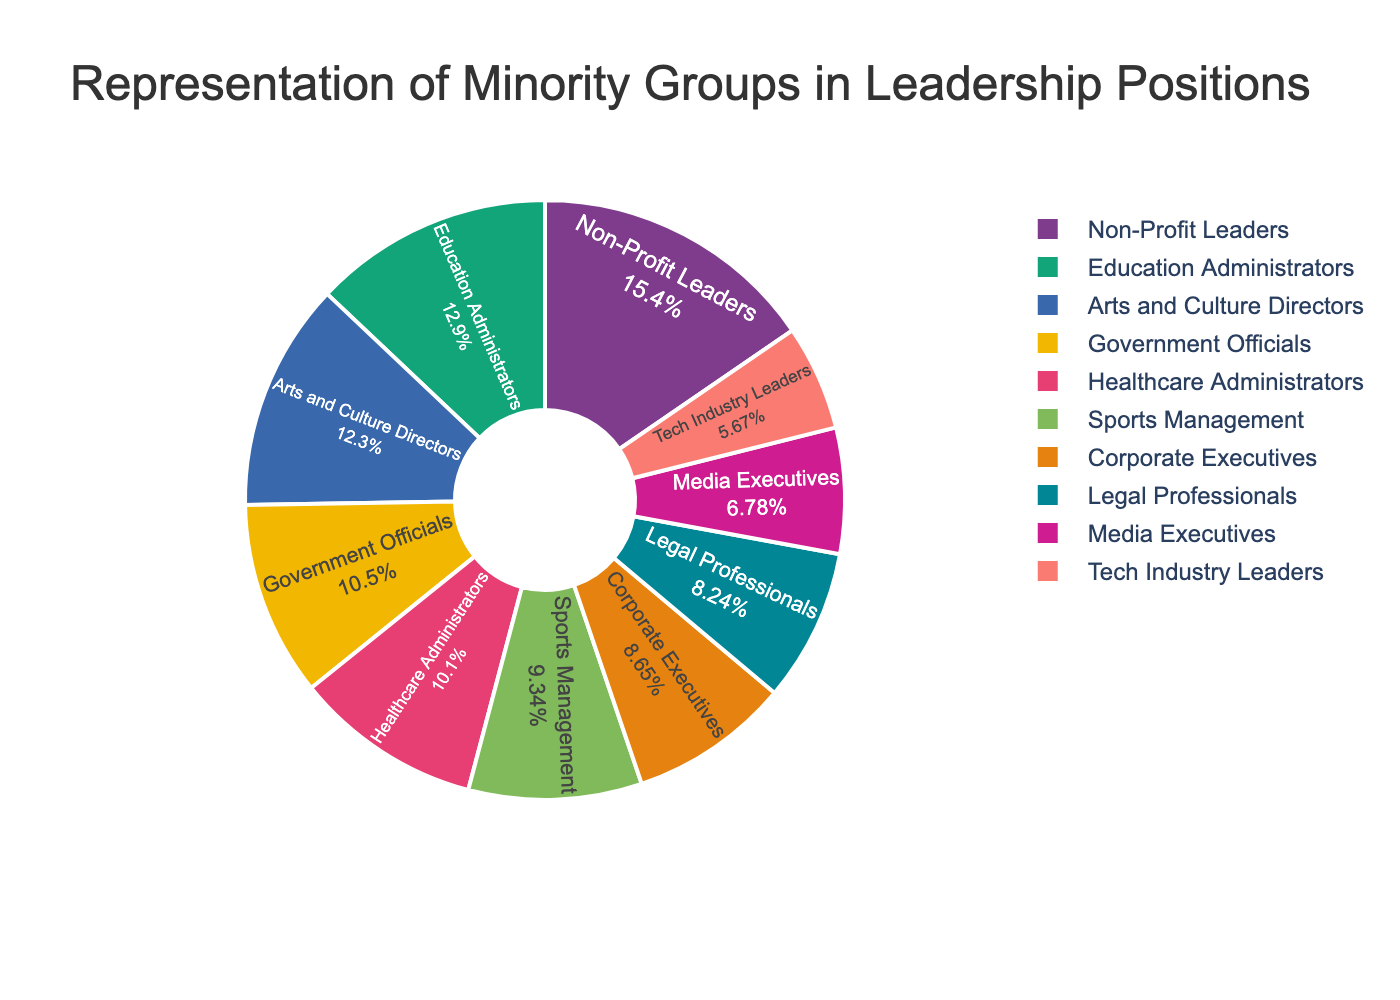Which sector has the highest percentage of minority representation? The chart shows the percentage of minority representation in different sectors. By looking at the percentage values for each sector, we can see that Non-Profit Leaders have the highest percentage at 22.3%.
Answer: Non-Profit Leaders Which sector has the lowest percentage of minority representation? By comparing the percentage values of each sector in the chart, we find that Tech Industry Leaders have the lowest percentage at 8.2%.
Answer: Tech Industry Leaders How much higher is the percentage of minority representation in Non-Profit Leaders compared to Media Executives? The percentage for Non-Profit Leaders is 22.3%, and for Media Executives, it is 9.8%. The difference can be calculated as 22.3% - 9.8% = 12.5%.
Answer: 12.5% What is the combined percentage of minority representation in Government Officials and Education Administrators? The chart shows that Government Officials have 15.2% representation and Education Administrators have 18.7%. Adding these together, we get 15.2% + 18.7% = 33.9%.
Answer: 33.9% Are there more sectors with minority representation percentages greater than 15% or less than 15%? To answer this, count the sectors with more than 15% representation (Government Officials, Education Administrators, Non-Profit Leaders, and Arts and Culture Directors) which are 4 sectors. Then count the sectors with less than 15% (Corporate Executives, Media Executives, Healthcare Administrators, Legal Professionals, Tech Industry Leaders, and Sports Management) which are 6 sectors. There are more sectors with less than 15%.
Answer: Less than 15% What is the average percentage of minority representation across all sectors? To find the average, add all the percentage values together and divide by the number of sectors. (12.5 + 15.2 + 18.7 + 22.3 + 9.8 + 14.6 + 11.9 + 8.2 + 17.8 + 13.5) / 10 = 144.5 / 10 = 14.45%.
Answer: 14.45% What is the difference in minority representation between Corporate Executives and Healthcare Administrators? Corporate Executives have 12.5% and Healthcare Administrators have 14.6%. The difference is 14.6% - 12.5% = 2.1%.
Answer: 2.1% Which sector has a percentage closest to 15%? The chart shows various percentages, and the percentage closest to 15% is Government Officials with 15.2%.
Answer: Government Officials How many sectors have more than 10% but less than 20% minority representation? By visually tallying the sectors that fall within the 10% to 20% range: Corporate Executives (12.5%), Government Officials (15.2%), Education Administrators (18.7%), Healthcare Administrators (14.6%), Legal Professionals (11.9%), Arts and Culture Directors (17.8%), and Sports Management (13.5%)—we count 7 sectors.
Answer: 7 What is the median percentage value of minority representation across the sectors? To find the median, list the percentages in order: 8.2%, 9.8%, 11.9%, 12.5%, 13.5%, 14.6%, 15.2%, 17.8%, 18.7%, 22.3%. The median will be the average of the 5th and 6th values because there are 10 data points. Median = (13.5% + 14.6%) / 2 = 14.05%.
Answer: 14.05% 